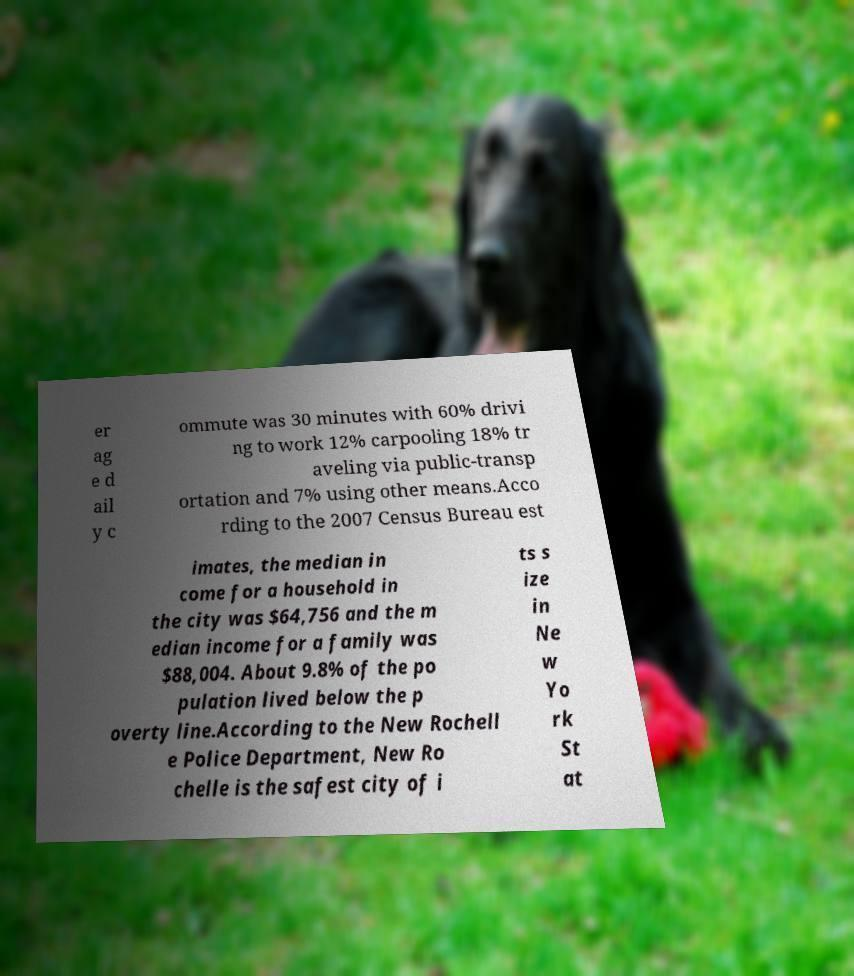Could you extract and type out the text from this image? er ag e d ail y c ommute was 30 minutes with 60% drivi ng to work 12% carpooling 18% tr aveling via public-transp ortation and 7% using other means.Acco rding to the 2007 Census Bureau est imates, the median in come for a household in the city was $64,756 and the m edian income for a family was $88,004. About 9.8% of the po pulation lived below the p overty line.According to the New Rochell e Police Department, New Ro chelle is the safest city of i ts s ize in Ne w Yo rk St at 